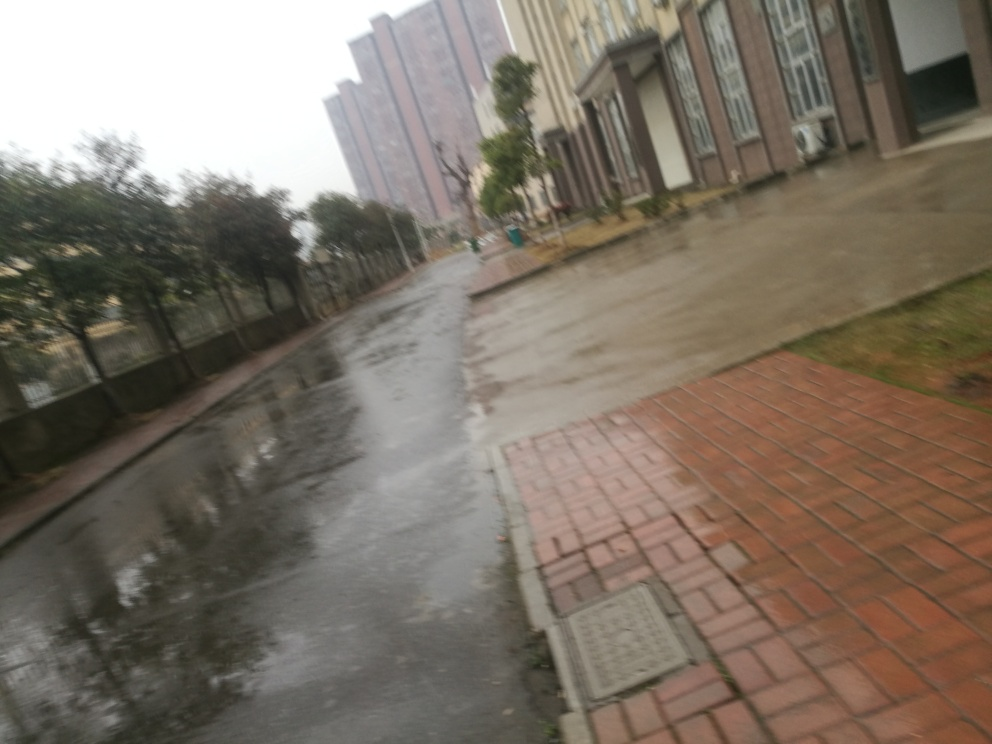What is the quality of the image? The image quality is relatively low. It appears blurry, potentially due to camera movement or focus issues. The overall composition is somewhat cluttered and lacks sharpness, which detracts from the clarity of elements within the scene. 